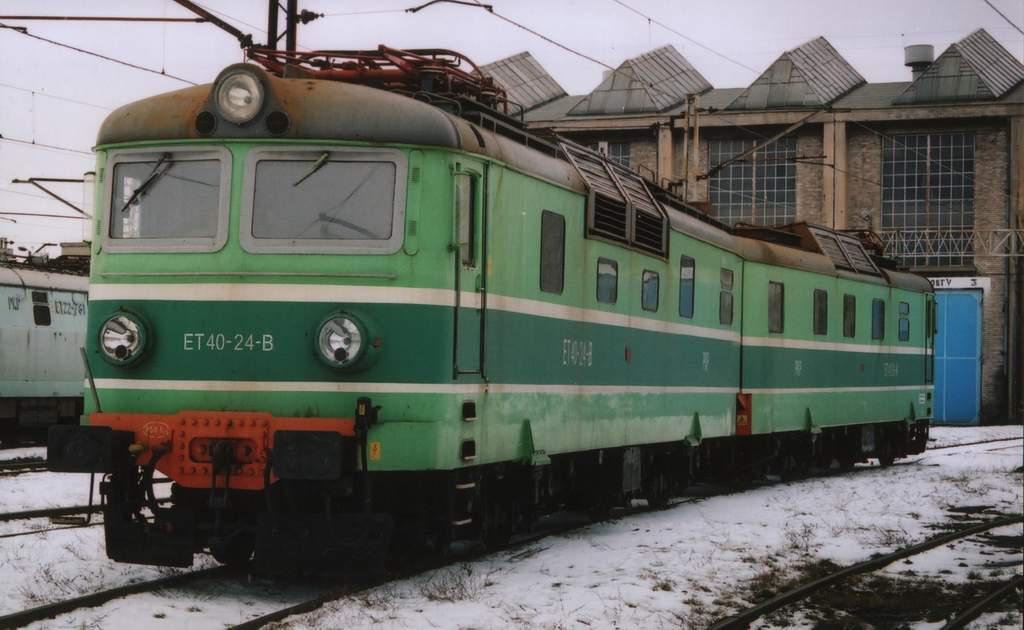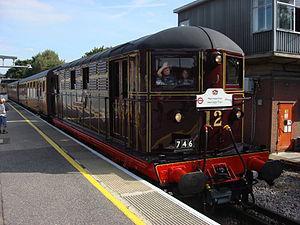The first image is the image on the left, the second image is the image on the right. Given the left and right images, does the statement "A train locomotive in each image is a distinct style and color, and positioned at a different angle than that of the other image." hold true? Answer yes or no. Yes. The first image is the image on the left, the second image is the image on the right. For the images shown, is this caption "People are standing by a railing next to a train in one image." true? Answer yes or no. No. 